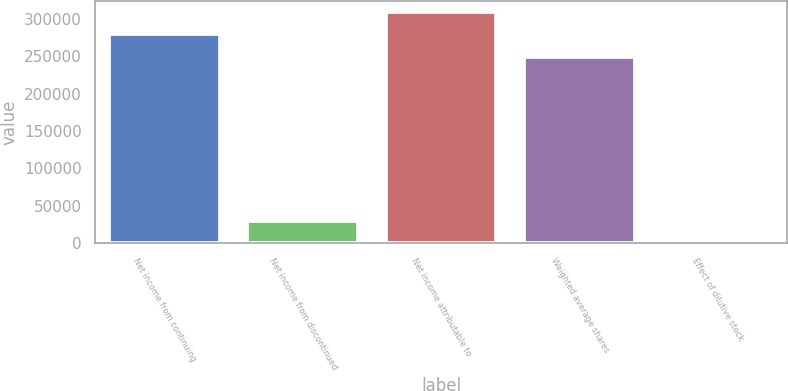Convert chart to OTSL. <chart><loc_0><loc_0><loc_500><loc_500><bar_chart><fcel>Net income from continuing<fcel>Net income from discontinued<fcel>Net income attributable to<fcel>Weighted average shares<fcel>Effect of dilutive stock<nl><fcel>279006<fcel>29691.2<fcel>308676<fcel>249337<fcel>22<nl></chart> 